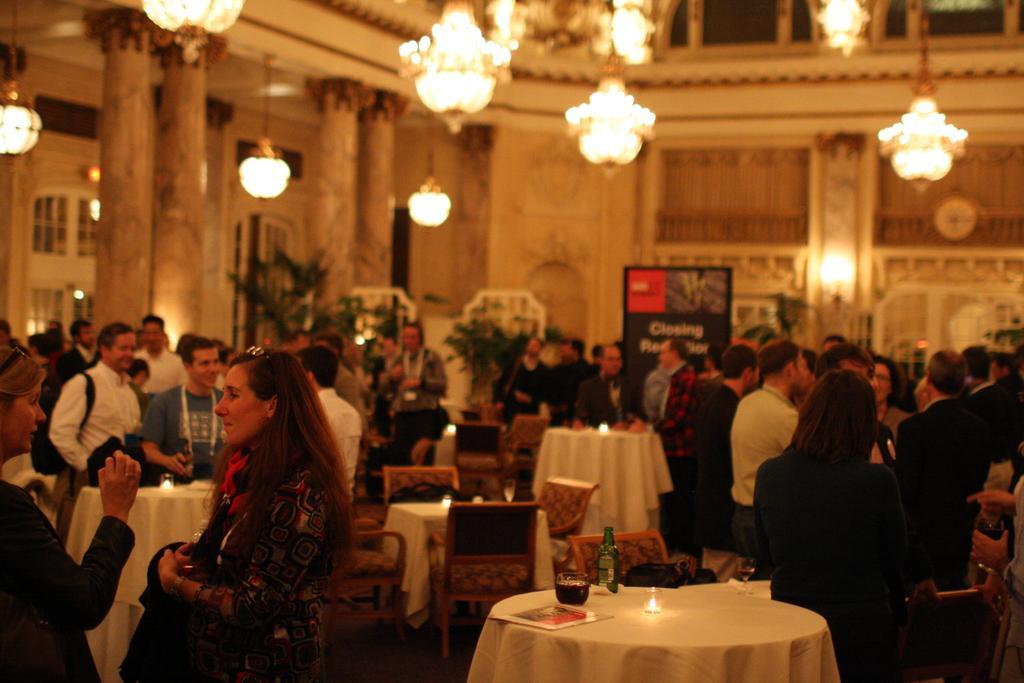Describe this image in one or two sentences. In this image I can see number of people are standing. I can also see few tables and chairs. 